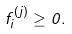<formula> <loc_0><loc_0><loc_500><loc_500>f _ { i } ^ { ( j ) } \geq 0 .</formula> 